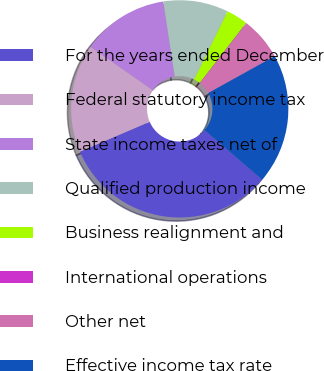Convert chart to OTSL. <chart><loc_0><loc_0><loc_500><loc_500><pie_chart><fcel>For the years ended December<fcel>Federal statutory income tax<fcel>State income taxes net of<fcel>Qualified production income<fcel>Business realignment and<fcel>International operations<fcel>Other net<fcel>Effective income tax rate<nl><fcel>32.26%<fcel>16.13%<fcel>12.9%<fcel>9.68%<fcel>3.23%<fcel>0.0%<fcel>6.45%<fcel>19.35%<nl></chart> 